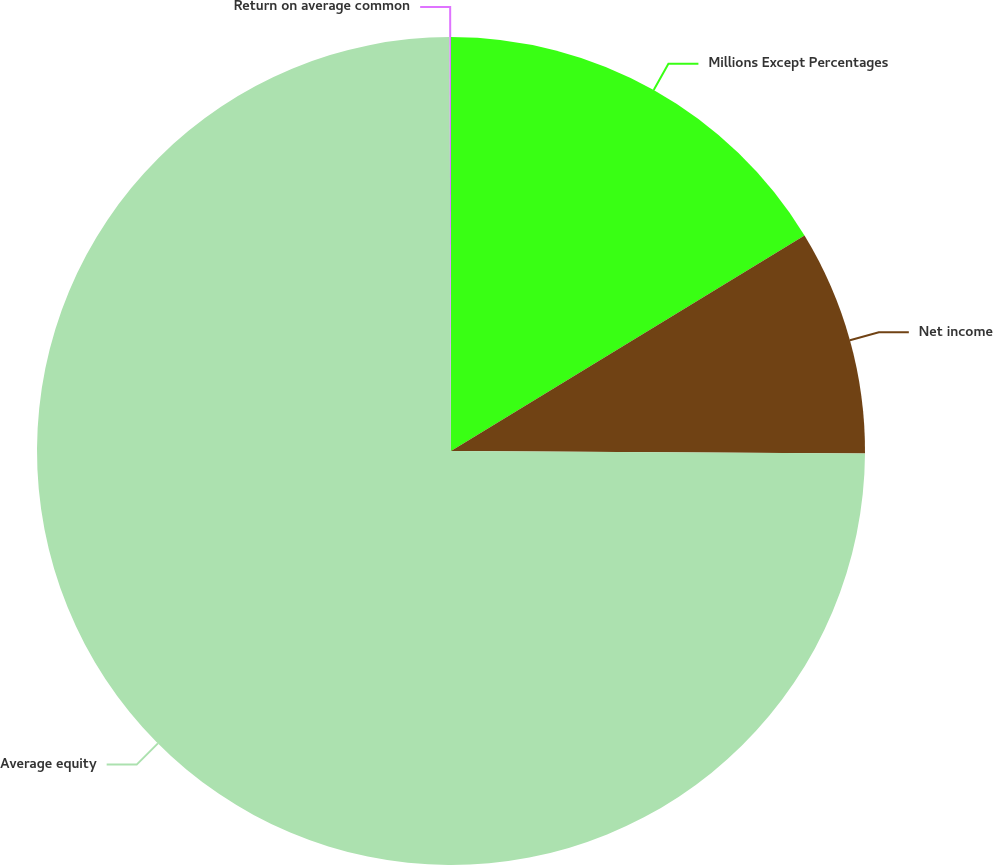<chart> <loc_0><loc_0><loc_500><loc_500><pie_chart><fcel>Millions Except Percentages<fcel>Net income<fcel>Average equity<fcel>Return on average common<nl><fcel>16.29%<fcel>8.81%<fcel>74.85%<fcel>0.06%<nl></chart> 